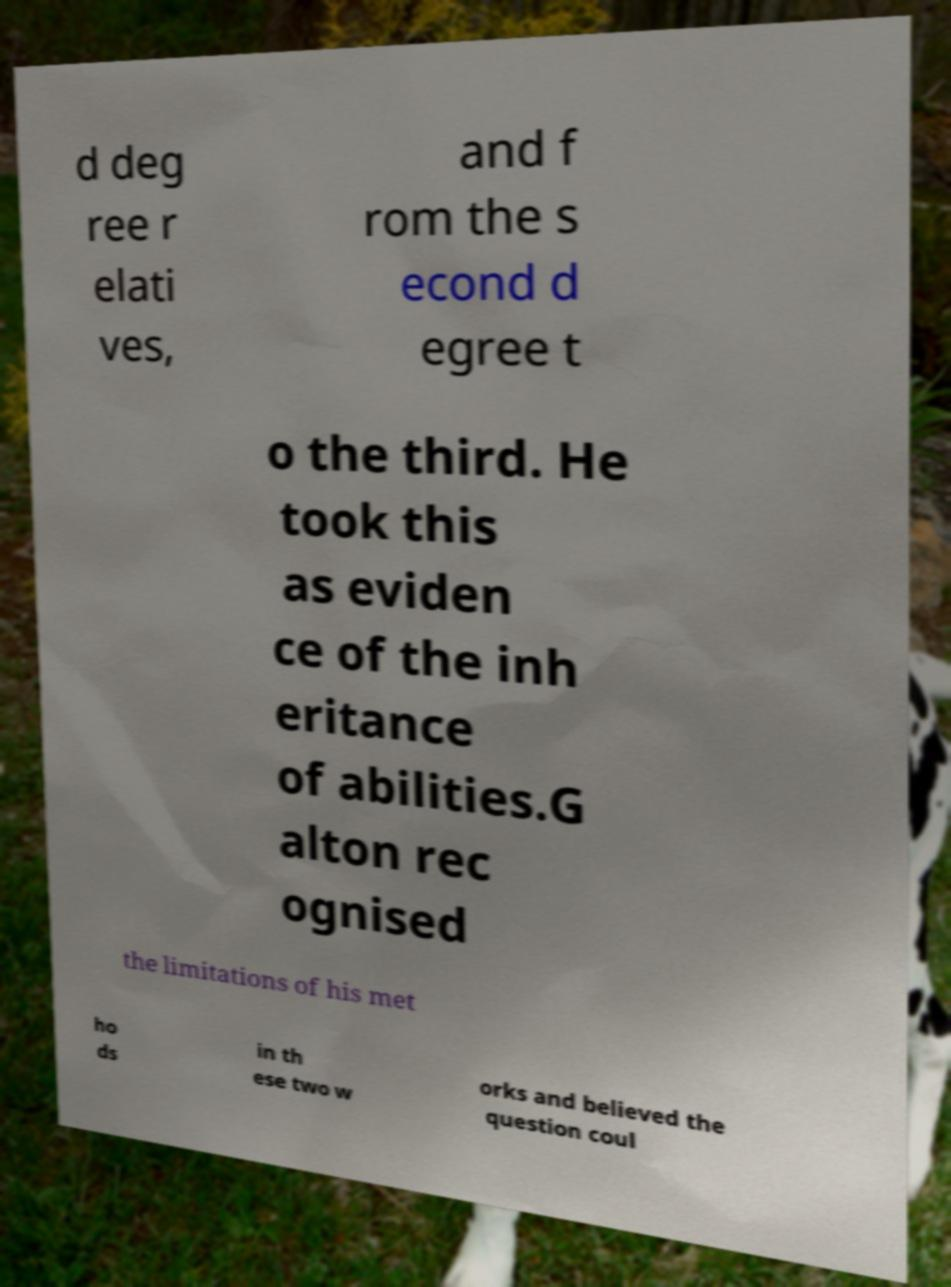I need the written content from this picture converted into text. Can you do that? d deg ree r elati ves, and f rom the s econd d egree t o the third. He took this as eviden ce of the inh eritance of abilities.G alton rec ognised the limitations of his met ho ds in th ese two w orks and believed the question coul 